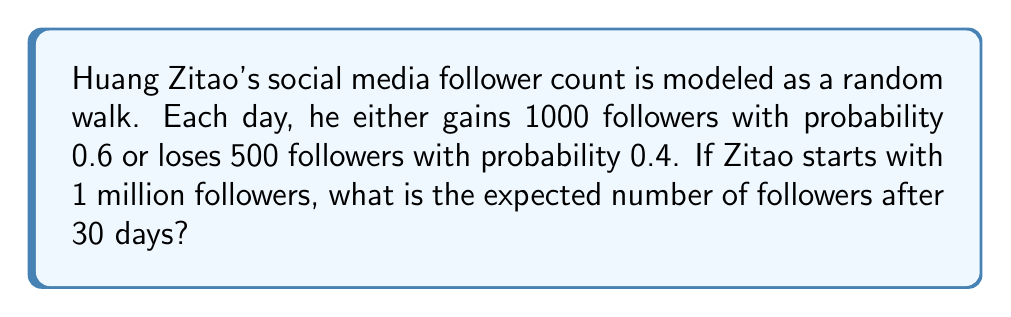Can you solve this math problem? Let's approach this step-by-step:

1) First, we need to calculate the expected change in followers per day:
   $E[\text{daily change}] = 1000 \cdot 0.6 + (-500) \cdot 0.4 = 600 - 200 = 400$

2) This means that on average, Zitao gains 400 followers per day.

3) For a random walk, the expected position after $n$ steps is given by:
   $E[X_n] = X_0 + n \cdot E[\text{step size}]$

   Where $X_0$ is the initial position and $n$ is the number of steps.

4) In this case:
   $X_0 = 1,000,000$ (initial followers)
   $n = 30$ (days)
   $E[\text{step size}] = 400$ (expected daily change)

5) Plugging these into our formula:
   $E[X_{30}] = 1,000,000 + 30 \cdot 400 = 1,000,000 + 12,000 = 1,012,000$

Therefore, the expected number of followers after 30 days is 1,012,000.
Answer: 1,012,000 followers 